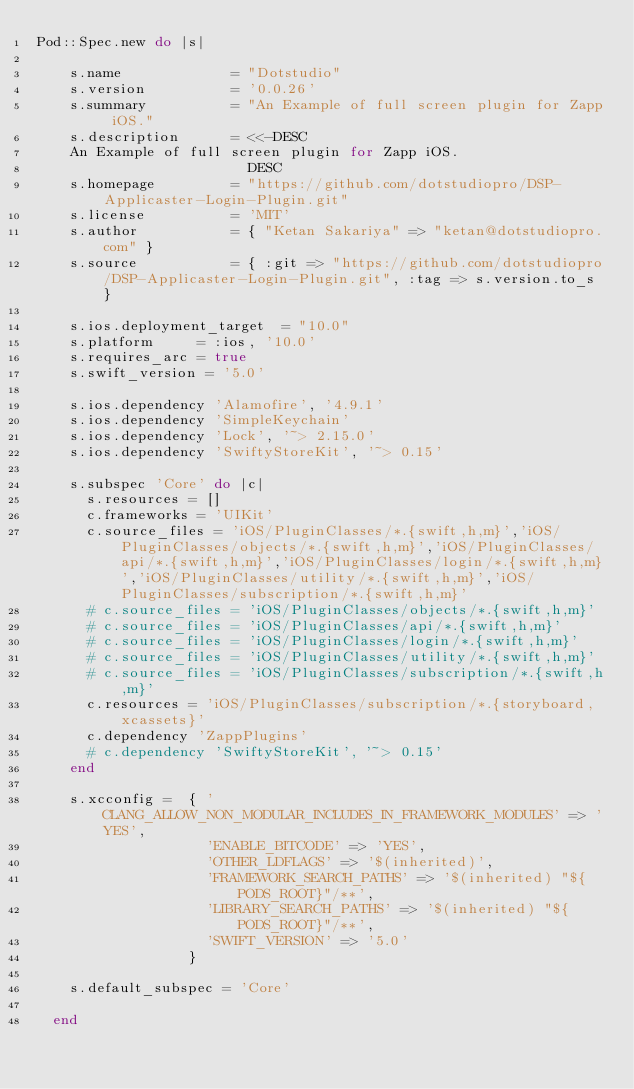<code> <loc_0><loc_0><loc_500><loc_500><_Ruby_>Pod::Spec.new do |s|

    s.name             = "Dotstudio"
    s.version          = '0.0.26'
    s.summary          = "An Example of full screen plugin for Zapp iOS."
    s.description      = <<-DESC
    An Example of full screen plugin for Zapp iOS.
                         DESC
    s.homepage         = "https://github.com/dotstudiopro/DSP-Applicaster-Login-Plugin.git"
    s.license          = 'MIT'
    s.author           = { "Ketan Sakariya" => "ketan@dotstudiopro.com" }
    s.source           = { :git => "https://github.com/dotstudiopro/DSP-Applicaster-Login-Plugin.git", :tag => s.version.to_s }
  
    s.ios.deployment_target  = "10.0"
    s.platform     = :ios, '10.0'
    s.requires_arc = true
    s.swift_version = '5.0'
   
    s.ios.dependency 'Alamofire', '4.9.1'
    s.ios.dependency 'SimpleKeychain'
    s.ios.dependency 'Lock', '~> 2.15.0'
    s.ios.dependency 'SwiftyStoreKit', '~> 0.15'

    s.subspec 'Core' do |c|
      s.resources = []
      c.frameworks = 'UIKit'
      c.source_files = 'iOS/PluginClasses/*.{swift,h,m}','iOS/PluginClasses/objects/*.{swift,h,m}','iOS/PluginClasses/api/*.{swift,h,m}','iOS/PluginClasses/login/*.{swift,h,m}','iOS/PluginClasses/utility/*.{swift,h,m}','iOS/PluginClasses/subscription/*.{swift,h,m}'
      # c.source_files = 'iOS/PluginClasses/objects/*.{swift,h,m}'
      # c.source_files = 'iOS/PluginClasses/api/*.{swift,h,m}'
      # c.source_files = 'iOS/PluginClasses/login/*.{swift,h,m}'
      # c.source_files = 'iOS/PluginClasses/utility/*.{swift,h,m}'
      # c.source_files = 'iOS/PluginClasses/subscription/*.{swift,h,m}'
      c.resources = 'iOS/PluginClasses/subscription/*.{storyboard,xcassets}'
      c.dependency 'ZappPlugins'
      # c.dependency 'SwiftyStoreKit', '~> 0.15'
    end
                  
    s.xcconfig =  { 'CLANG_ALLOW_NON_MODULAR_INCLUDES_IN_FRAMEWORK_MODULES' => 'YES',
                    'ENABLE_BITCODE' => 'YES',
                    'OTHER_LDFLAGS' => '$(inherited)',
                    'FRAMEWORK_SEARCH_PATHS' => '$(inherited) "${PODS_ROOT}"/**',
                    'LIBRARY_SEARCH_PATHS' => '$(inherited) "${PODS_ROOT}"/**',
                    'SWIFT_VERSION' => '5.0'
                  }
                  
    s.default_subspec = 'Core'
                  
  end
  </code> 